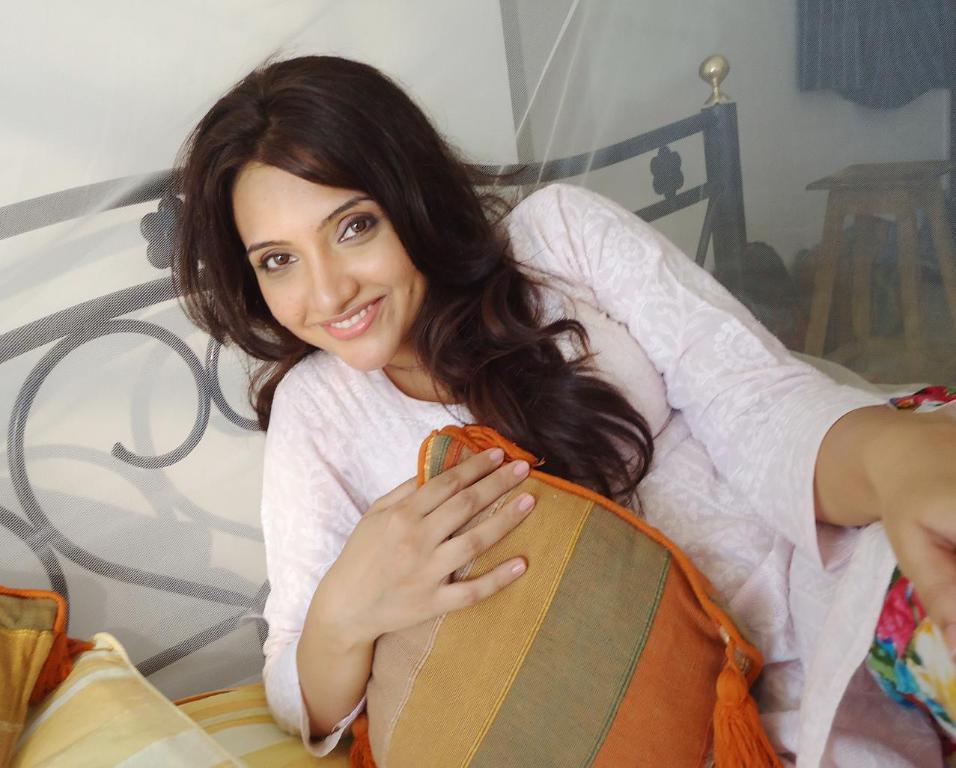In one or two sentences, can you explain what this image depicts? In this picture we can see the woman lying on the bed, smiling and giving a pose to the camera. Behind we can see the black pipe bed and white net curtain. In the background there is a white wall. 